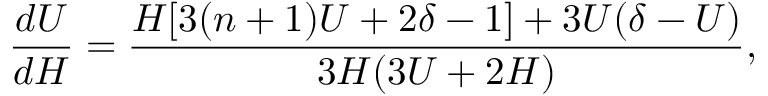Convert formula to latex. <formula><loc_0><loc_0><loc_500><loc_500>\frac { d U } { d H } = \frac { H [ 3 ( n + 1 ) U + 2 \delta - 1 ] + 3 U ( \delta - U ) } { 3 H ( 3 U + 2 H ) } ,</formula> 